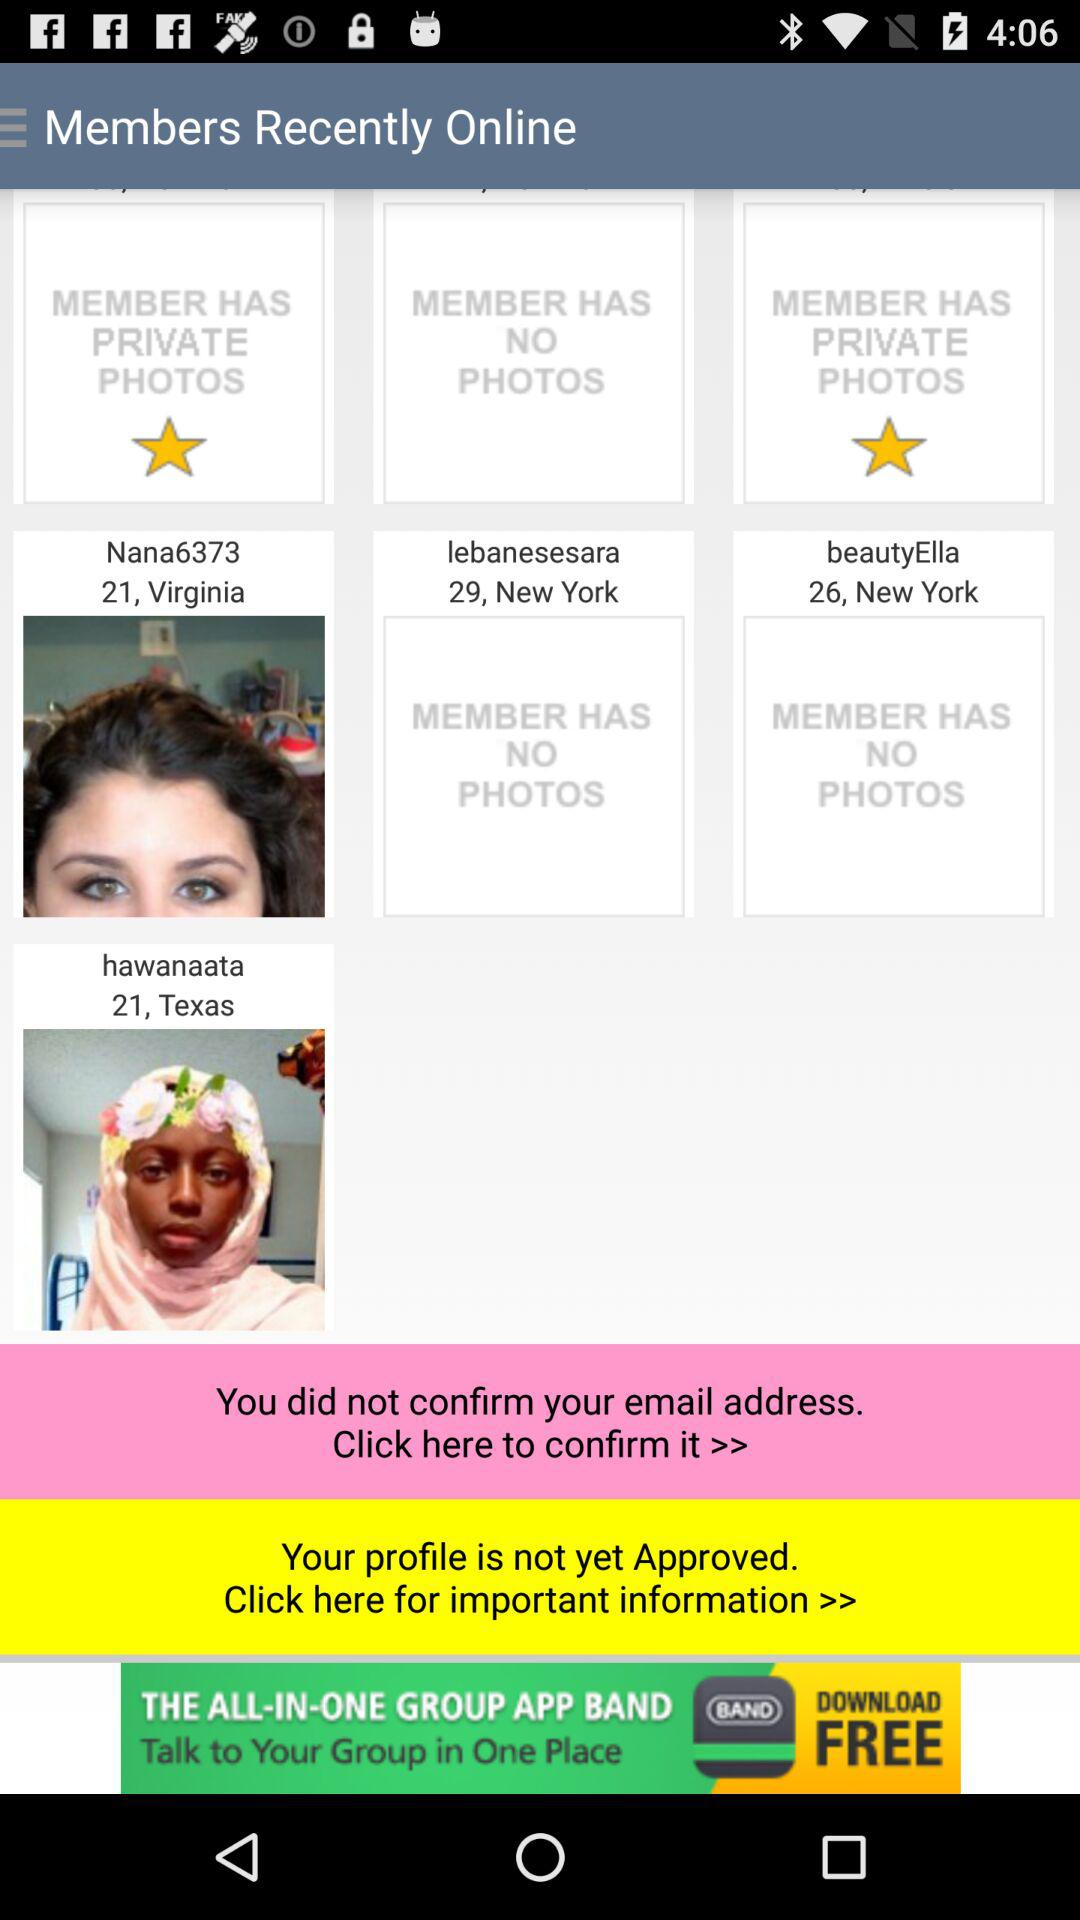What is the age of Nana6373? The age of Nana6373 is 21. 